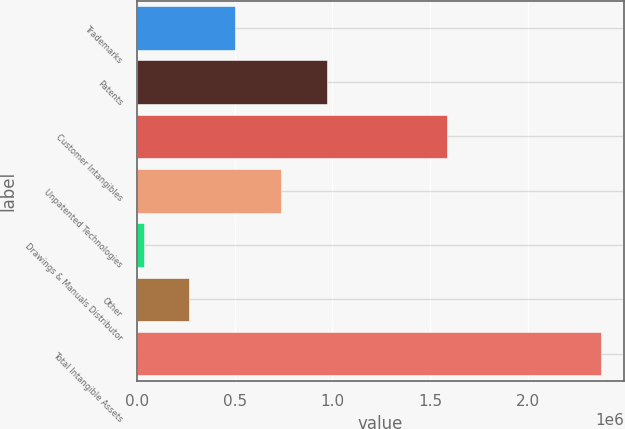Convert chart to OTSL. <chart><loc_0><loc_0><loc_500><loc_500><bar_chart><fcel>Trademarks<fcel>Patents<fcel>Customer Intangibles<fcel>Unpatented Technologies<fcel>Drawings & Manuals Distributor<fcel>Other<fcel>Total Intangible Assets<nl><fcel>502563<fcel>971006<fcel>1.58504e+06<fcel>736784<fcel>34120<fcel>268342<fcel>2.37634e+06<nl></chart> 